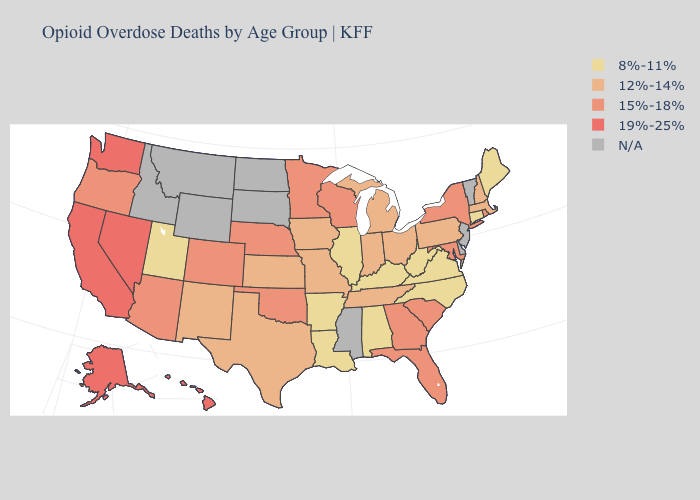What is the lowest value in the West?
Answer briefly. 8%-11%. What is the value of Ohio?
Short answer required. 12%-14%. Does Minnesota have the lowest value in the USA?
Give a very brief answer. No. Which states have the lowest value in the West?
Be succinct. Utah. How many symbols are there in the legend?
Answer briefly. 5. What is the value of Wyoming?
Write a very short answer. N/A. What is the highest value in the USA?
Give a very brief answer. 19%-25%. What is the value of Virginia?
Keep it brief. 8%-11%. Name the states that have a value in the range 15%-18%?
Write a very short answer. Arizona, Colorado, Florida, Georgia, Maryland, Minnesota, Nebraska, New York, Oklahoma, Oregon, Rhode Island, South Carolina, Wisconsin. Does Arkansas have the highest value in the USA?
Be succinct. No. What is the highest value in the USA?
Concise answer only. 19%-25%. What is the value of New Mexico?
Keep it brief. 12%-14%. Name the states that have a value in the range 12%-14%?
Be succinct. Indiana, Iowa, Kansas, Massachusetts, Michigan, Missouri, New Hampshire, New Mexico, Ohio, Pennsylvania, Tennessee, Texas. What is the lowest value in states that border Washington?
Give a very brief answer. 15%-18%. Which states hav the highest value in the South?
Give a very brief answer. Florida, Georgia, Maryland, Oklahoma, South Carolina. 